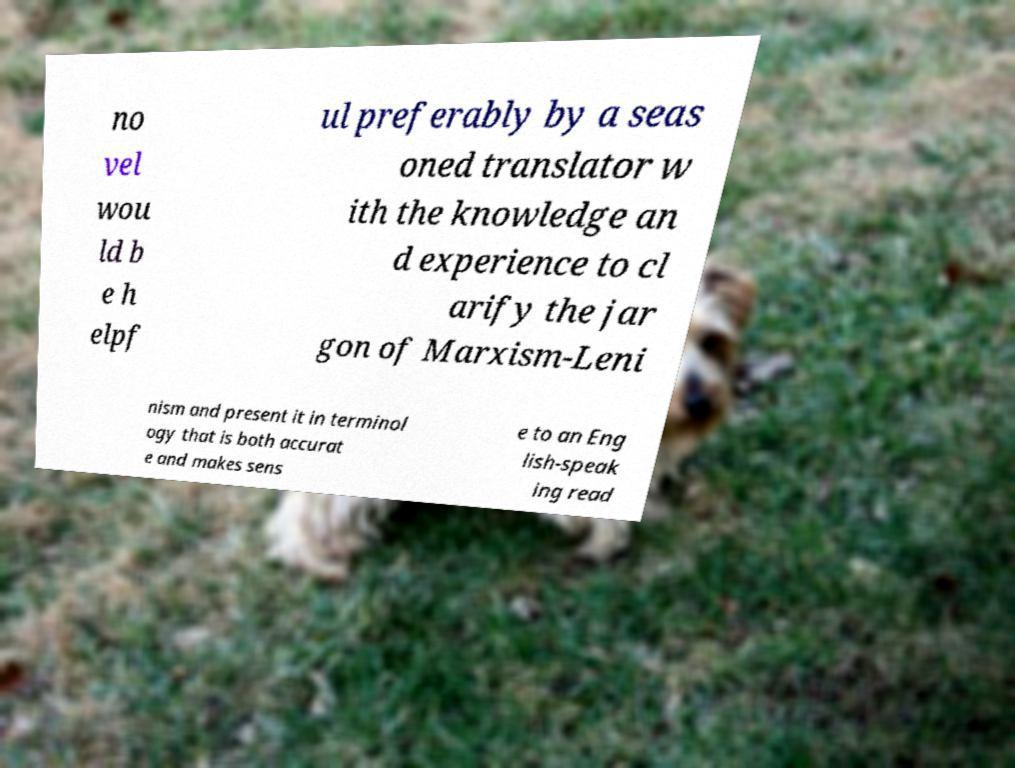Can you read and provide the text displayed in the image?This photo seems to have some interesting text. Can you extract and type it out for me? no vel wou ld b e h elpf ul preferably by a seas oned translator w ith the knowledge an d experience to cl arify the jar gon of Marxism-Leni nism and present it in terminol ogy that is both accurat e and makes sens e to an Eng lish-speak ing read 